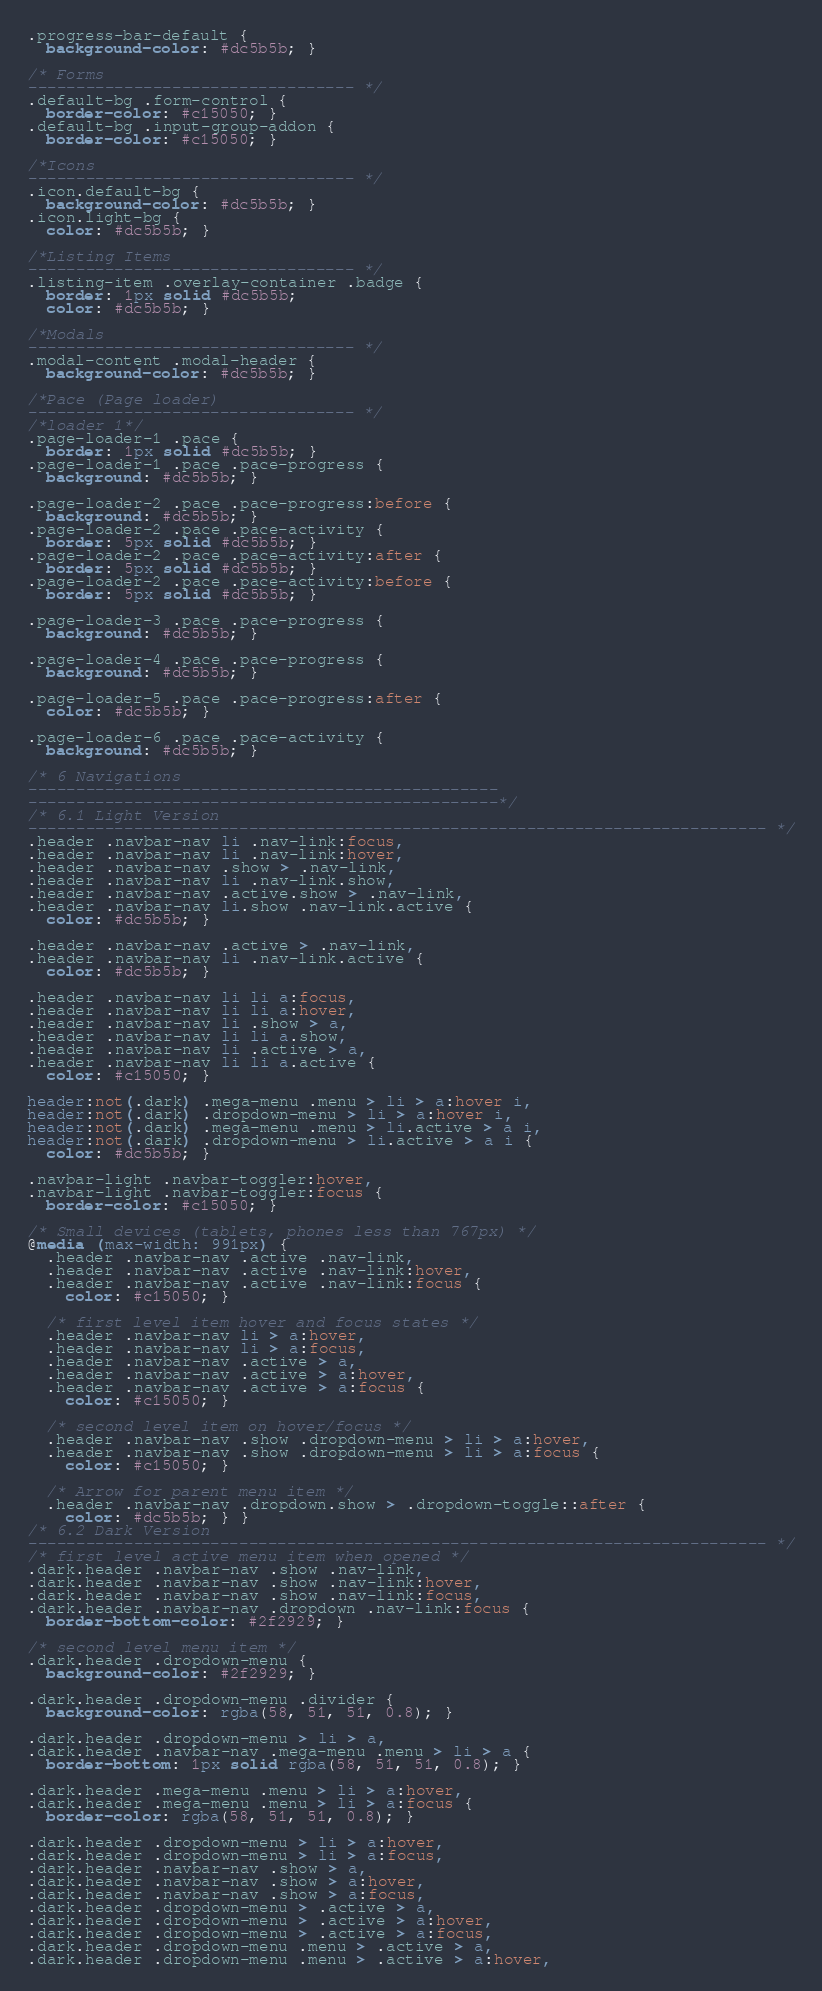Convert code to text. <code><loc_0><loc_0><loc_500><loc_500><_CSS_>.progress-bar-default {
  background-color: #dc5b5b; }

/* Forms
---------------------------------- */
.default-bg .form-control {
  border-color: #c15050; }
.default-bg .input-group-addon {
  border-color: #c15050; }

/*Icons
---------------------------------- */
.icon.default-bg {
  background-color: #dc5b5b; }
.icon.light-bg {
  color: #dc5b5b; }

/*Listing Items
---------------------------------- */
.listing-item .overlay-container .badge {
  border: 1px solid #dc5b5b;
  color: #dc5b5b; }

/*Modals
---------------------------------- */
.modal-content .modal-header {
  background-color: #dc5b5b; }

/*Pace (Page loader)
---------------------------------- */
/*loader 1*/
.page-loader-1 .pace {
  border: 1px solid #dc5b5b; }
.page-loader-1 .pace .pace-progress {
  background: #dc5b5b; }

.page-loader-2 .pace .pace-progress:before {
  background: #dc5b5b; }
.page-loader-2 .pace .pace-activity {
  border: 5px solid #dc5b5b; }
.page-loader-2 .pace .pace-activity:after {
  border: 5px solid #dc5b5b; }
.page-loader-2 .pace .pace-activity:before {
  border: 5px solid #dc5b5b; }

.page-loader-3 .pace .pace-progress {
  background: #dc5b5b; }

.page-loader-4 .pace .pace-progress {
  background: #dc5b5b; }

.page-loader-5 .pace .pace-progress:after {
  color: #dc5b5b; }

.page-loader-6 .pace .pace-activity {
  background: #dc5b5b; }

/* 6 Navigations
-------------------------------------------------
-------------------------------------------------*/
/* 6.1 Light Version
----------------------------------------------------------------------------- */
.header .navbar-nav li .nav-link:focus,
.header .navbar-nav li .nav-link:hover,
.header .navbar-nav .show > .nav-link,
.header .navbar-nav li .nav-link.show,
.header .navbar-nav .active.show > .nav-link,
.header .navbar-nav li.show .nav-link.active {
  color: #dc5b5b; }

.header .navbar-nav .active > .nav-link,
.header .navbar-nav li .nav-link.active {
  color: #dc5b5b; }

.header .navbar-nav li li a:focus,
.header .navbar-nav li li a:hover,
.header .navbar-nav li .show > a,
.header .navbar-nav li li a.show,
.header .navbar-nav li .active > a,
.header .navbar-nav li li a.active {
  color: #c15050; }

header:not(.dark) .mega-menu .menu > li > a:hover i,
header:not(.dark) .dropdown-menu > li > a:hover i,
header:not(.dark) .mega-menu .menu > li.active > a i,
header:not(.dark) .dropdown-menu > li.active > a i {
  color: #dc5b5b; }

.navbar-light .navbar-toggler:hover,
.navbar-light .navbar-toggler:focus {
  border-color: #c15050; }

/* Small devices (tablets, phones less than 767px) */
@media (max-width: 991px) {
  .header .navbar-nav .active .nav-link,
  .header .navbar-nav .active .nav-link:hover,
  .header .navbar-nav .active .nav-link:focus {
    color: #c15050; }

  /* first level item hover and focus states */
  .header .navbar-nav li > a:hover,
  .header .navbar-nav li > a:focus,
  .header .navbar-nav .active > a,
  .header .navbar-nav .active > a:hover,
  .header .navbar-nav .active > a:focus {
    color: #c15050; }

  /* second level item on hover/focus */
  .header .navbar-nav .show .dropdown-menu > li > a:hover,
  .header .navbar-nav .show .dropdown-menu > li > a:focus {
    color: #c15050; }

  /* Arrow for parent menu item */
  .header .navbar-nav .dropdown.show > .dropdown-toggle::after {
    color: #dc5b5b; } }
/* 6.2 Dark Version
----------------------------------------------------------------------------- */
/* first level active menu item when opened */
.dark.header .navbar-nav .show .nav-link,
.dark.header .navbar-nav .show .nav-link:hover,
.dark.header .navbar-nav .show .nav-link:focus,
.dark.header .navbar-nav .dropdown .nav-link:focus {
  border-bottom-color: #2f2929; }

/* second level menu item */
.dark.header .dropdown-menu {
  background-color: #2f2929; }

.dark.header .dropdown-menu .divider {
  background-color: rgba(58, 51, 51, 0.8); }

.dark.header .dropdown-menu > li > a,
.dark.header .navbar-nav .mega-menu .menu > li > a {
  border-bottom: 1px solid rgba(58, 51, 51, 0.8); }

.dark.header .mega-menu .menu > li > a:hover,
.dark.header .mega-menu .menu > li > a:focus {
  border-color: rgba(58, 51, 51, 0.8); }

.dark.header .dropdown-menu > li > a:hover,
.dark.header .dropdown-menu > li > a:focus,
.dark.header .navbar-nav .show > a,
.dark.header .navbar-nav .show > a:hover,
.dark.header .navbar-nav .show > a:focus,
.dark.header .dropdown-menu > .active > a,
.dark.header .dropdown-menu > .active > a:hover,
.dark.header .dropdown-menu > .active > a:focus,
.dark.header .dropdown-menu .menu > .active > a,
.dark.header .dropdown-menu .menu > .active > a:hover,</code> 